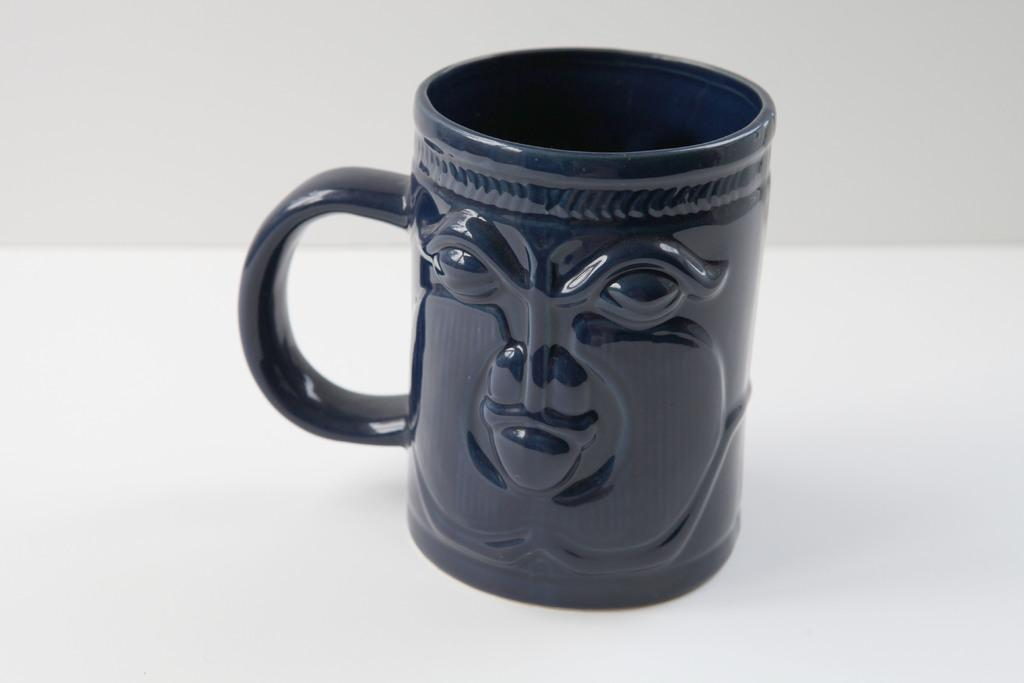What object is in the center of the image? There is a ceramic mug in the center of the image. What type of art can be seen on the ceramic mug in the image? There is no information about any art on the ceramic mug in the image. How many ladybugs are crawling on the ceramic mug in the image? There are no ladybugs present on the ceramic mug in the image. 